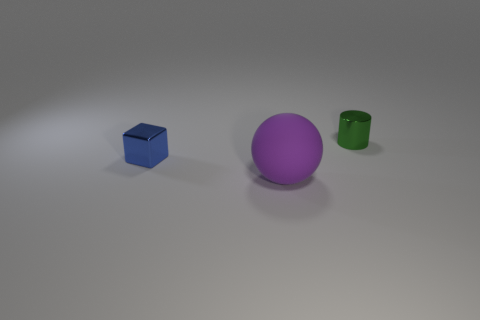Is there any other thing that is the same size as the rubber object?
Provide a succinct answer. No. The shiny cube in front of the tiny object that is right of the rubber ball is what color?
Offer a terse response. Blue. There is a tiny object that is on the right side of the tiny shiny thing to the left of the small cylinder; is there a blue block that is in front of it?
Offer a very short reply. Yes. Is there any other thing of the same color as the tiny metal cylinder?
Provide a short and direct response. No. Are there any large blue matte cubes?
Your answer should be very brief. No. Is there another blue cube that has the same material as the block?
Ensure brevity in your answer.  No. Is there anything else that is made of the same material as the big ball?
Offer a very short reply. No. The large thing is what color?
Your response must be concise. Purple. The shiny cylinder that is the same size as the blue cube is what color?
Your answer should be very brief. Green. How many matte objects are either tiny red blocks or large purple balls?
Ensure brevity in your answer.  1. 